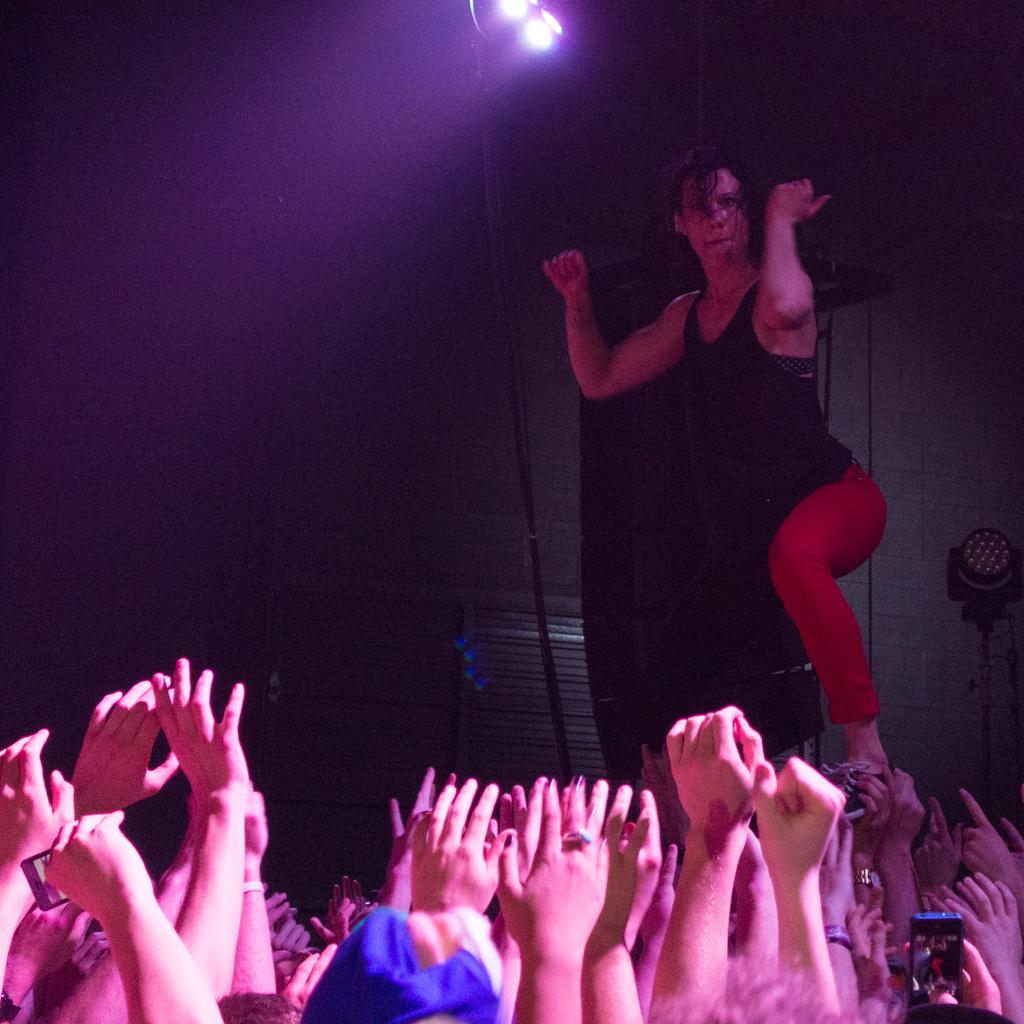What is the main subject of the image at the bottom? There is a group of hands visible at the bottom of the image. What is being depicted on the hands? A person is depicted on the hands. What can be seen at the top of the image? There are lights visible at the top of the image. How many kittens are playing with the substance in the image? There are no kittens or substance present in the image. What type of selection is being made in the image? There is no selection process depicted in the image; it features a group of hands with a person on them and lights at the top. 